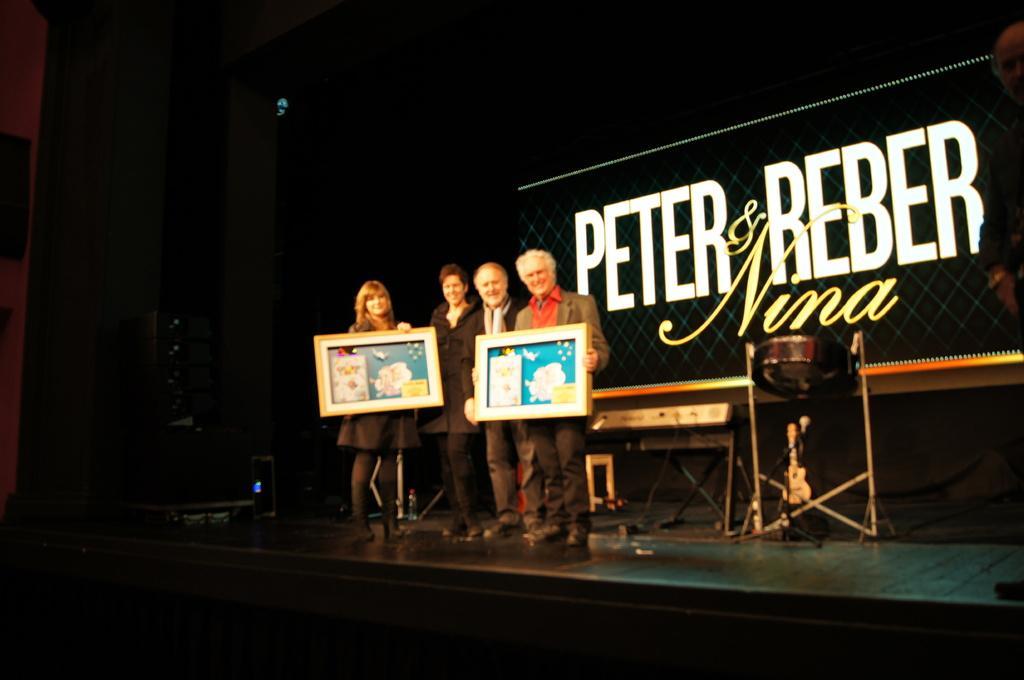Could you give a brief overview of what you see in this image? In the image I can see four people, among them two are holding the frames and behind there is a desk and something written. 